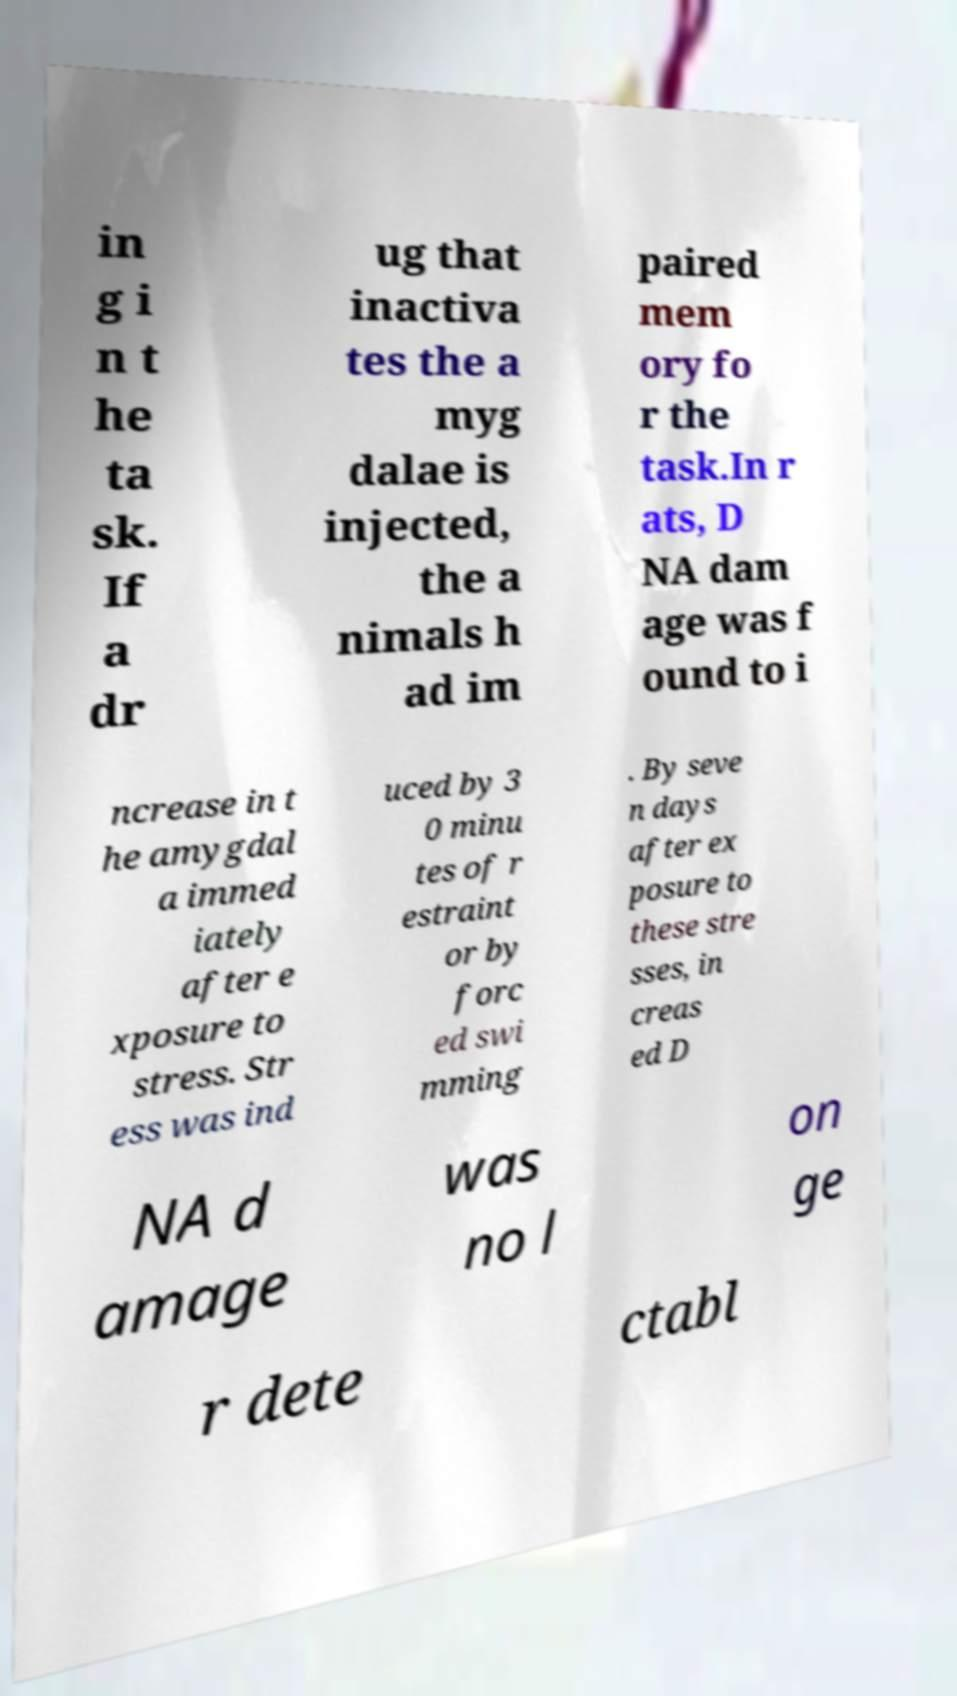For documentation purposes, I need the text within this image transcribed. Could you provide that? in g i n t he ta sk. If a dr ug that inactiva tes the a myg dalae is injected, the a nimals h ad im paired mem ory fo r the task.In r ats, D NA dam age was f ound to i ncrease in t he amygdal a immed iately after e xposure to stress. Str ess was ind uced by 3 0 minu tes of r estraint or by forc ed swi mming . By seve n days after ex posure to these stre sses, in creas ed D NA d amage was no l on ge r dete ctabl 